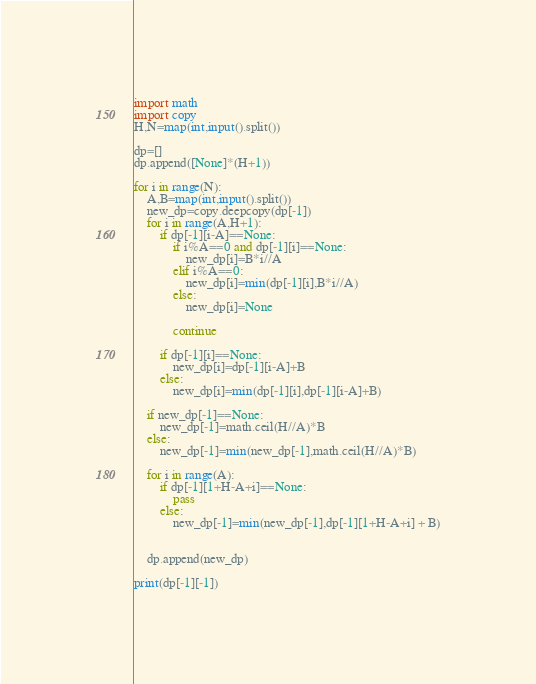<code> <loc_0><loc_0><loc_500><loc_500><_Python_>import math
import copy
H,N=map(int,input().split())

dp=[]
dp.append([None]*(H+1))

for i in range(N):
    A,B=map(int,input().split())
    new_dp=copy.deepcopy(dp[-1])
    for i in range(A,H+1):
        if dp[-1][i-A]==None:
            if i%A==0 and dp[-1][i]==None:
                new_dp[i]=B*i//A
            elif i%A==0:
                new_dp[i]=min(dp[-1][i],B*i//A)
            else:
                new_dp[i]=None

            continue

        if dp[-1][i]==None:
            new_dp[i]=dp[-1][i-A]+B
        else:
            new_dp[i]=min(dp[-1][i],dp[-1][i-A]+B)
        
    if new_dp[-1]==None:
        new_dp[-1]=math.ceil(H//A)*B
    else:
        new_dp[-1]=min(new_dp[-1],math.ceil(H//A)*B)

    for i in range(A):
        if dp[-1][1+H-A+i]==None:
            pass
        else:
            new_dp[-1]=min(new_dp[-1],dp[-1][1+H-A+i] + B)
    

    dp.append(new_dp)

print(dp[-1][-1])</code> 